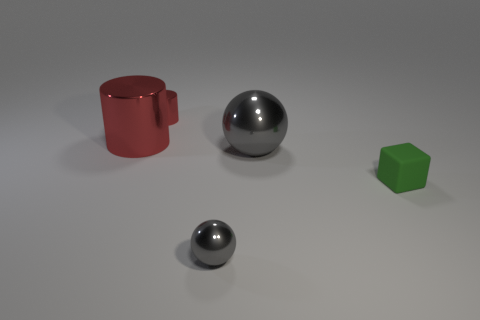Add 1 big red metallic cylinders. How many objects exist? 6 Subtract all spheres. How many objects are left? 3 Add 3 matte cubes. How many matte cubes exist? 4 Subtract 1 green blocks. How many objects are left? 4 Subtract all big gray balls. Subtract all tiny gray balls. How many objects are left? 3 Add 4 tiny things. How many tiny things are left? 7 